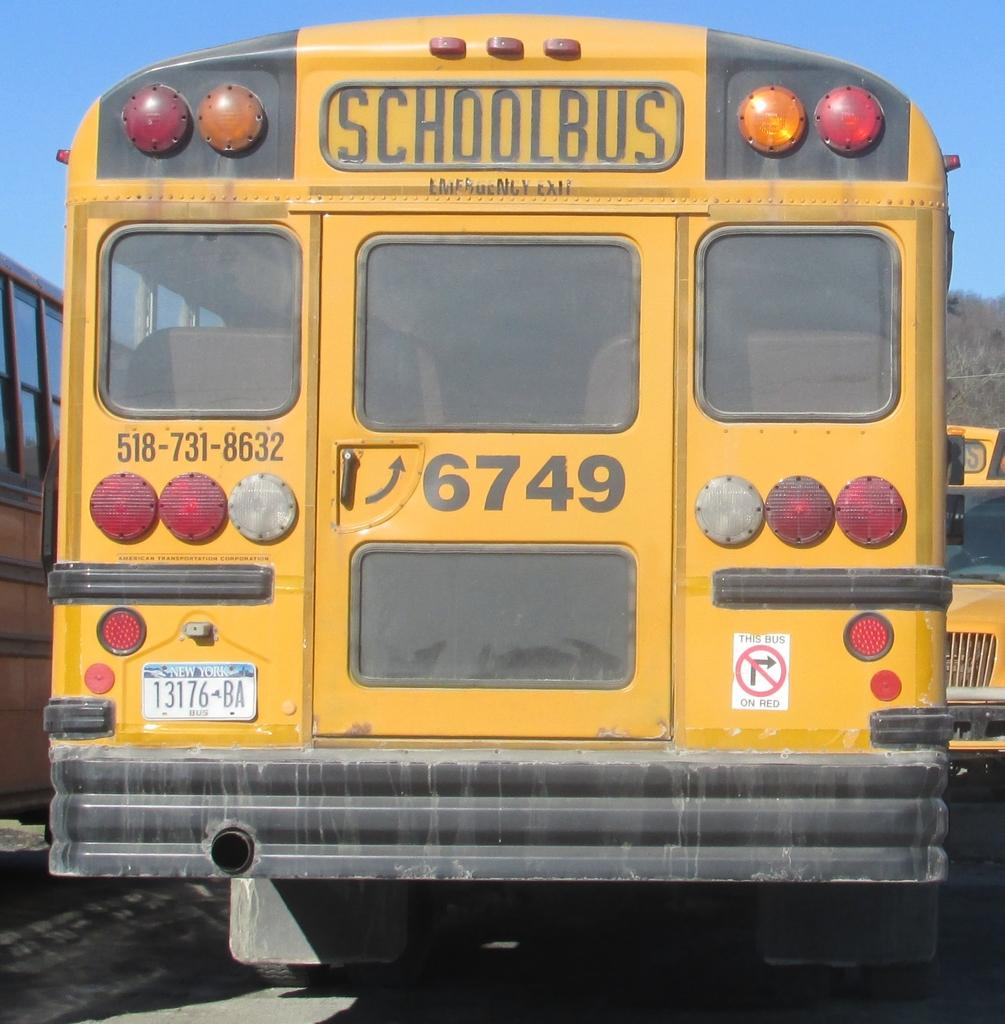<image>
Write a terse but informative summary of the picture. Back of a schoolbus with the numbers 6749 on it. 